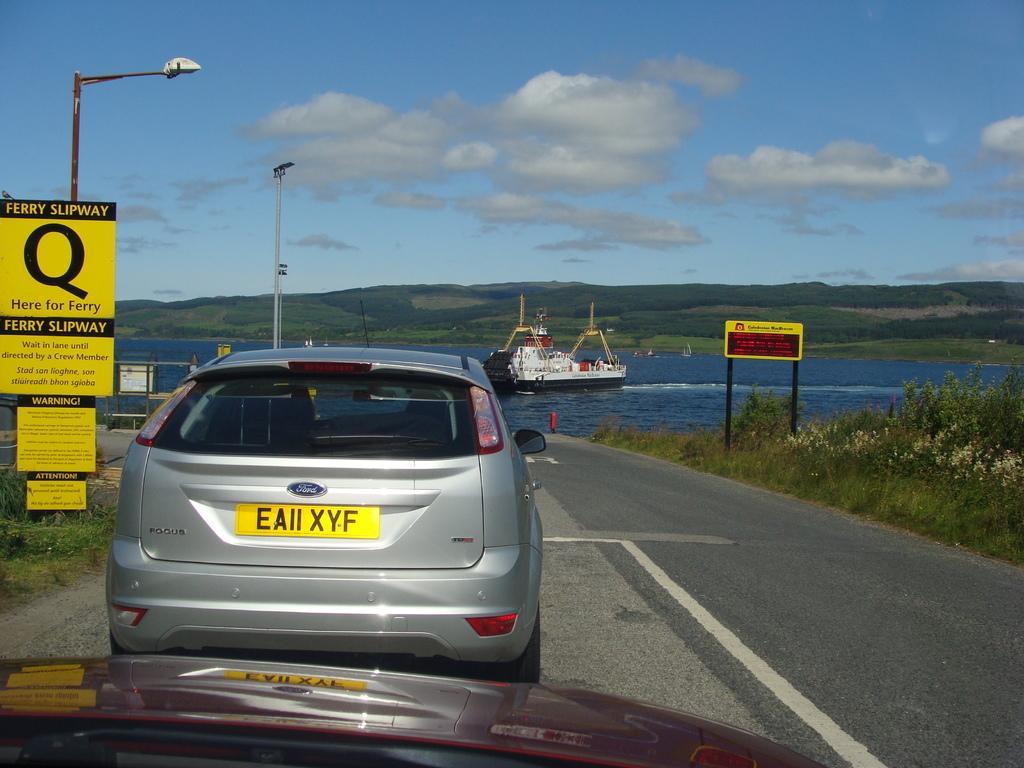Can you describe this image briefly? In this image there are two vehicles on the road, boards and lights attached to the poles, grass, plants, ship on the water,and in the background there are hills,sky. 